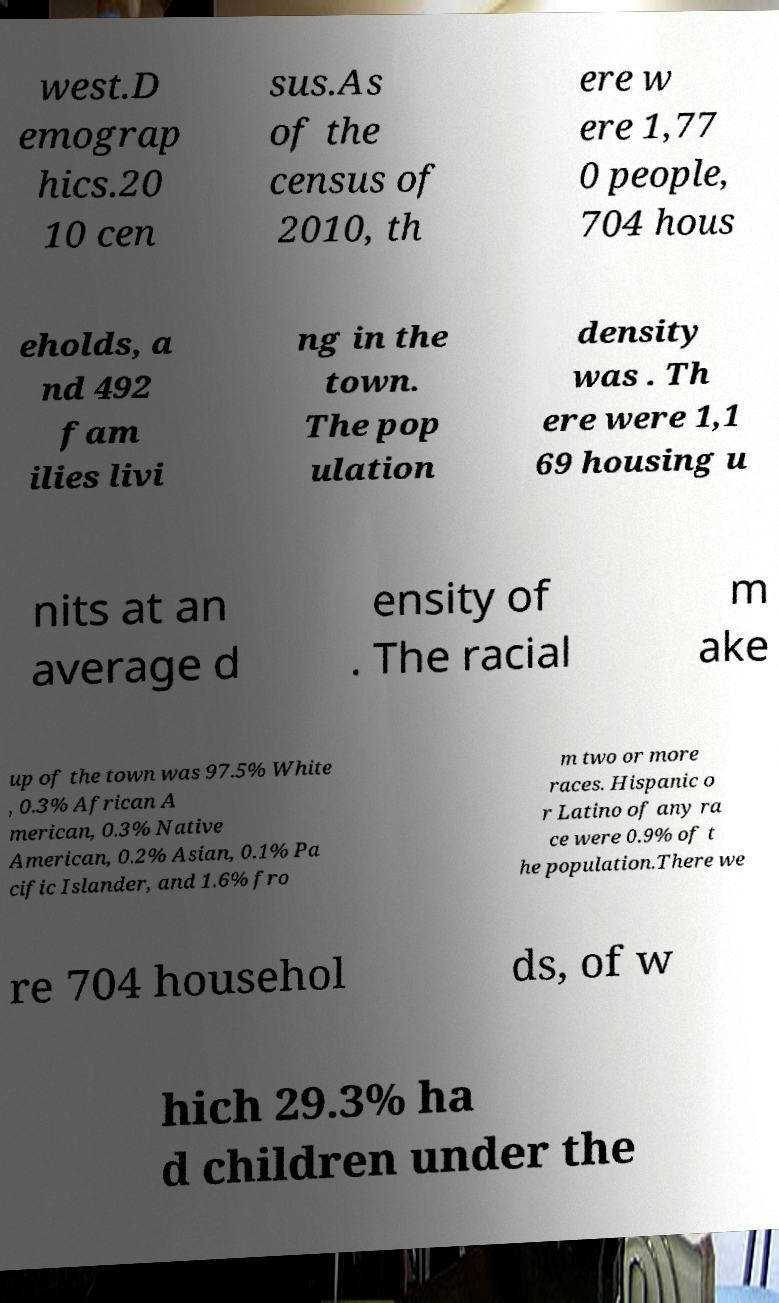Can you read and provide the text displayed in the image?This photo seems to have some interesting text. Can you extract and type it out for me? west.D emograp hics.20 10 cen sus.As of the census of 2010, th ere w ere 1,77 0 people, 704 hous eholds, a nd 492 fam ilies livi ng in the town. The pop ulation density was . Th ere were 1,1 69 housing u nits at an average d ensity of . The racial m ake up of the town was 97.5% White , 0.3% African A merican, 0.3% Native American, 0.2% Asian, 0.1% Pa cific Islander, and 1.6% fro m two or more races. Hispanic o r Latino of any ra ce were 0.9% of t he population.There we re 704 househol ds, of w hich 29.3% ha d children under the 